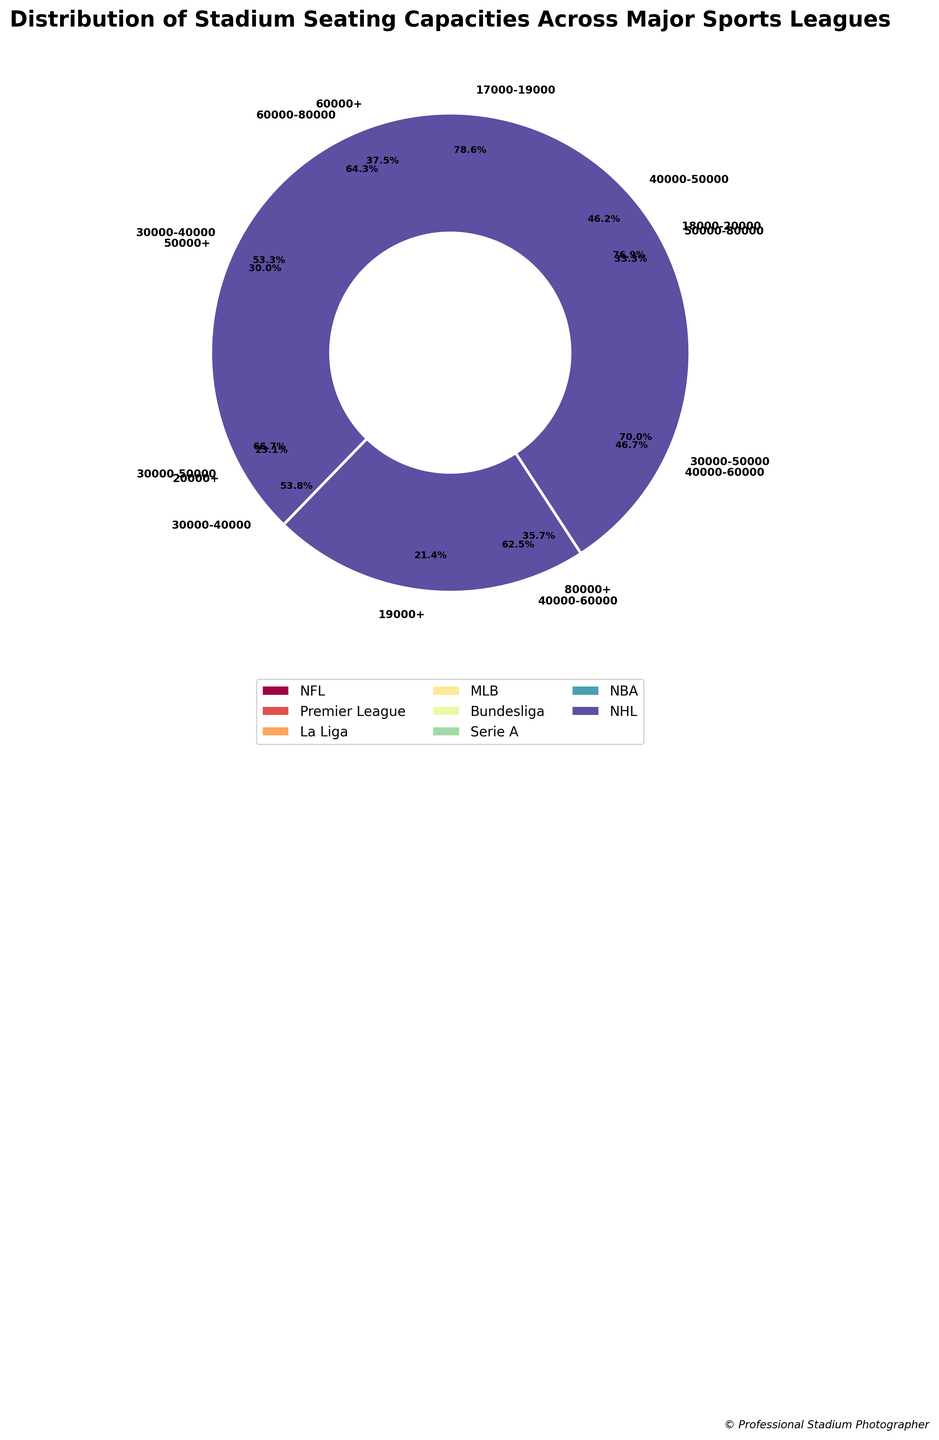What's the total number of stadiums in the NFL with seating capacities 60,000-80,000? The pie chart segments labeled "60,000-80,000" for NFL stadiums can be summed up directly because each segment represents one capacity range within the NFL. For NFL, the "60,000-80,000" segment states 18 stadiums.
Answer: 18 Which league has the most stadiums with seating capacities over 80,000? To determine which league has the most stadiums in the "80,000+" category, we need to compare the pie chart segments labeled as "80,000+" for different leagues. The NFL’s "80000+" segment has 10 stadiums, while no other league has this category explicitly shown in the chart.
Answer: NFL How many major sports leagues include stadiums with seating capacities in the range 30,000-50,000? We need to look at the segments for each league in the chart and count those containing "30,000-50,000" ranges. Premier League ("30,000-40,000": 8), La Liga ("30,000-50,000": 12), Serie A ("30,000-50,000": 14), and MLB ("30,000-40,000": 14) all have this range. So four leagues have this range.
Answer: 4 How does the number of NBA stadiums with the largest seating capacity compare to the number of NHL stadiums with the largest seating capacity? The comparison involves the "20,000+" category for NBA and the "19,000+" category for NHL. The NBA's "20,000+" segment shows 6 stadiums, and the NHL's "19,000+" segment also shows 6 stadiums. We compare these two numbers directly.
Answer: Equal How much larger is the stadium capacity range 40,000-60,000 in Bundesliga compared to Premier League? The Bundesliga's segment labeled "40,000-60,000" has 10 stadiums, and the Premier League's corresponding segment has 7 stadiums. Subtract these two numbers to get the difference.
Answer: 3 